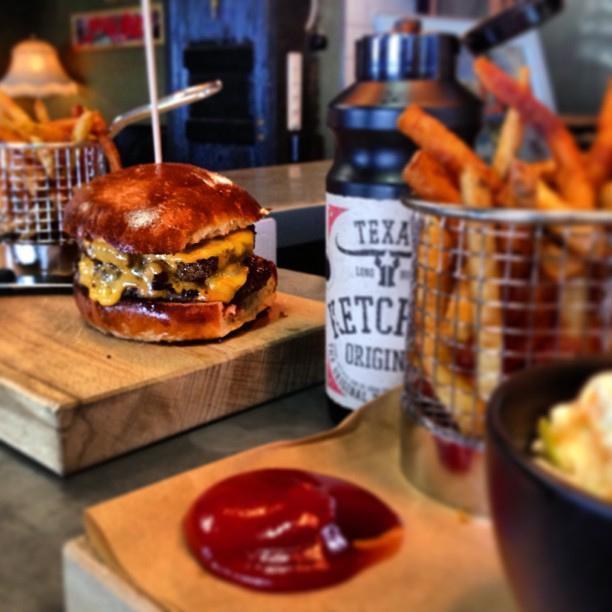Why is there a stick stuck in the cheeseburger?
Select the accurate response from the four choices given to answer the question.
Options: Appearance, joke, hold together, check temp. Hold together. 